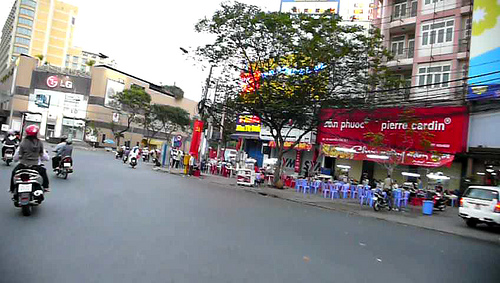Is the girl to the left of a person? Yes, the girl is standing to the left of a person in the image. 